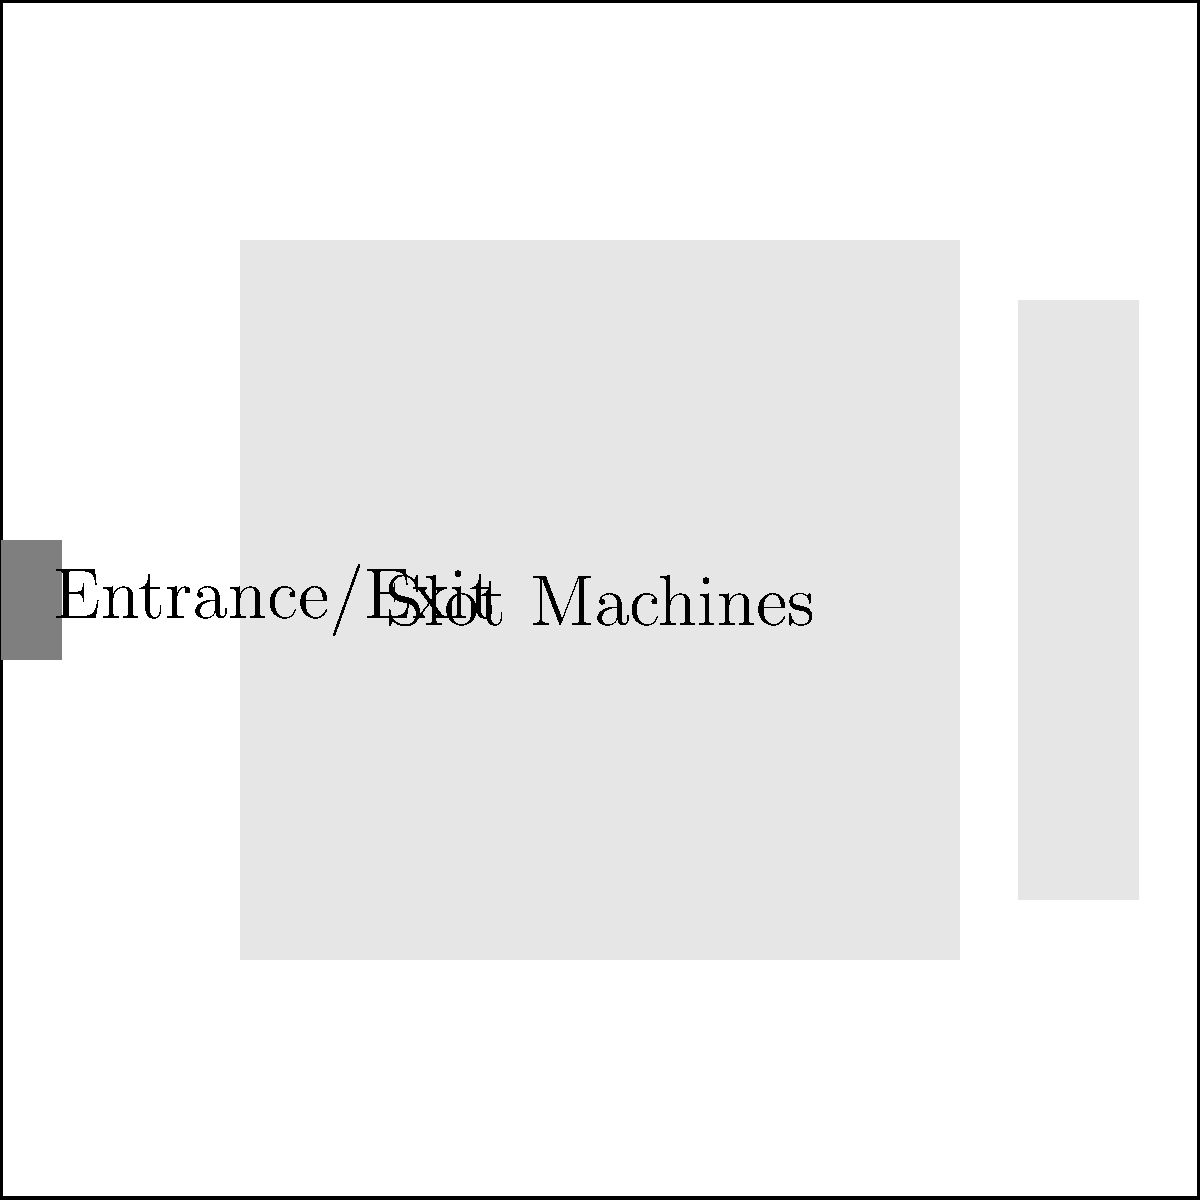Based on the casino floor layout shown, which path sequence would likely maximize customer spending by guiding them through the most profitable areas? To determine the optimal path for maximizing customer spending, we need to consider the following factors:

1. Slot machines are typically more profitable for casinos than table games.
2. Customers tend to spend more when they stay longer in the casino.
3. A path that exposes customers to various gaming options can increase overall spending.

Analyzing the paths:
A (blue): Leads customers directly from the entrance to the slot machine area.
B (red): Takes customers through the entire slot machine area.
C (green): Guides customers from the slot machines to the table games.
D (purple): Allows vertical movement within the slot machine area.

The optimal sequence would be:

1. Start with path A to lead customers into the casino.
2. Follow with path B to expose them to the entire slot machine area, where they're likely to spend the most.
3. Use path D to ensure customers explore different parts of the slot machine area, increasing time spent and potential spending.
4. End with path C to guide some customers to table games, offering variety and potentially attracting high-rollers.

This sequence (A → B → D → C) maximizes exposure to slot machines while also providing access to table games, likely resulting in the highest customer spending.
Answer: A → B → D → C 